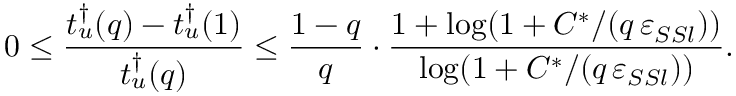Convert formula to latex. <formula><loc_0><loc_0><loc_500><loc_500>0 \leq \frac { t _ { u } ^ { \dagger } ( q ) - t _ { u } ^ { \dagger } ( 1 ) } { t _ { u } ^ { \dagger } ( q ) } \leq \frac { 1 - q } { q } \cdot \frac { 1 + \log ( 1 + C ^ { * } / ( q \, \varepsilon _ { S S l } ) ) } { \log ( 1 + C ^ { * } / ( q \, \varepsilon _ { S S l } ) ) } .</formula> 